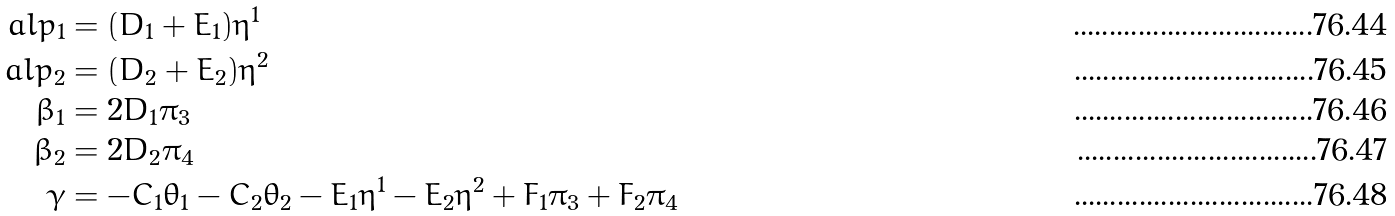<formula> <loc_0><loc_0><loc_500><loc_500>\ a l p _ { 1 } & = ( D _ { 1 } + E _ { 1 } ) \eta ^ { 1 } \\ \ a l p _ { 2 } & = ( D _ { 2 } + E _ { 2 } ) \eta ^ { 2 } \\ \beta _ { 1 } & = 2 D _ { 1 } \pi _ { 3 } \\ \beta _ { 2 } & = 2 D _ { 2 } \pi _ { 4 } \\ \gamma & = - C _ { 1 } \theta _ { 1 } - C _ { 2 } \theta _ { 2 } - E _ { 1 } \eta ^ { 1 } - E _ { 2 } \eta ^ { 2 } + F _ { 1 } \pi _ { 3 } + F _ { 2 } \pi _ { 4 }</formula> 